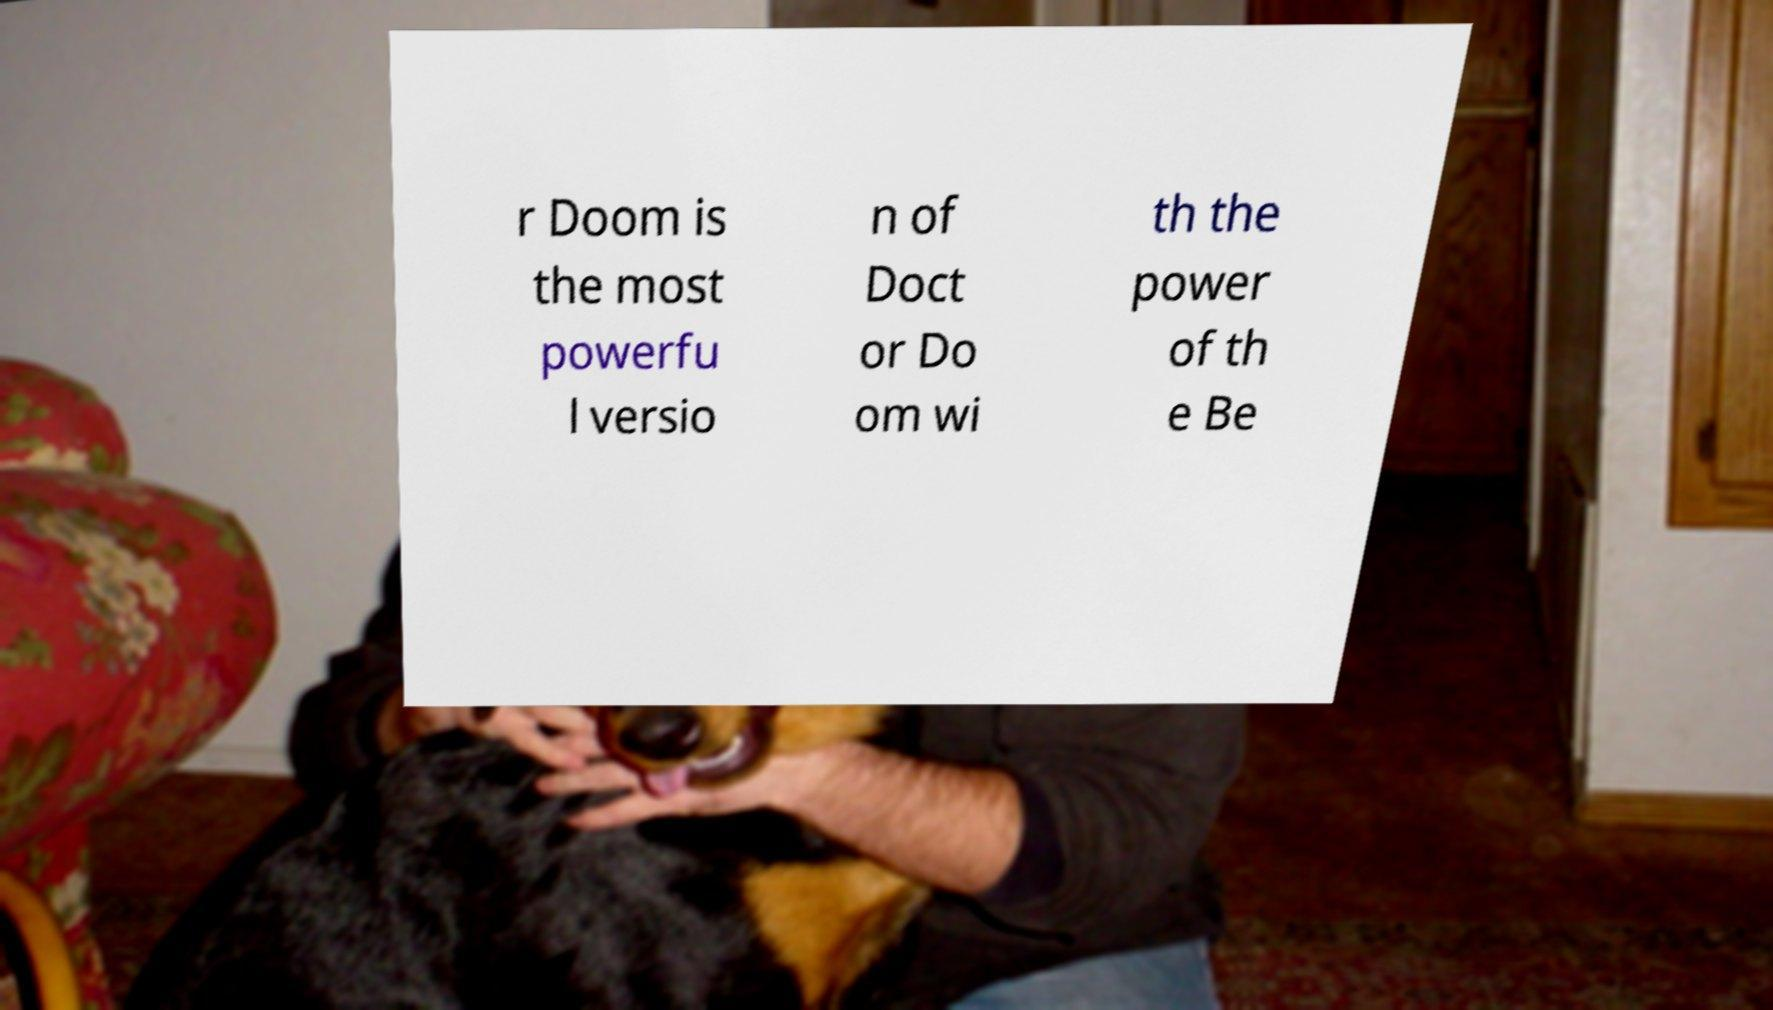I need the written content from this picture converted into text. Can you do that? r Doom is the most powerfu l versio n of Doct or Do om wi th the power of th e Be 